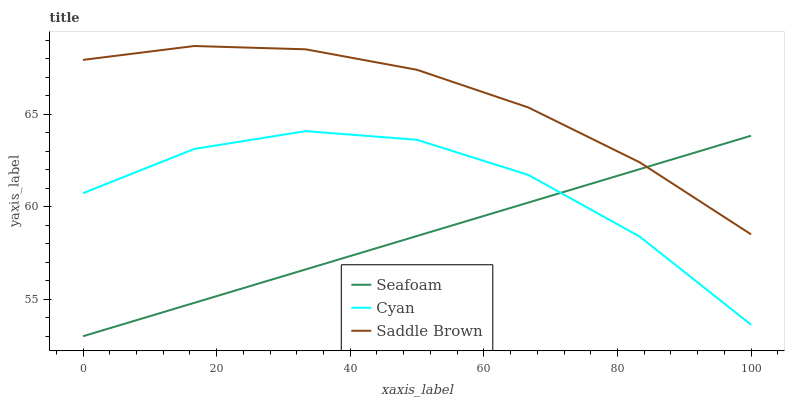Does Seafoam have the minimum area under the curve?
Answer yes or no. Yes. Does Saddle Brown have the maximum area under the curve?
Answer yes or no. Yes. Does Saddle Brown have the minimum area under the curve?
Answer yes or no. No. Does Seafoam have the maximum area under the curve?
Answer yes or no. No. Is Seafoam the smoothest?
Answer yes or no. Yes. Is Cyan the roughest?
Answer yes or no. Yes. Is Saddle Brown the smoothest?
Answer yes or no. No. Is Saddle Brown the roughest?
Answer yes or no. No. Does Saddle Brown have the lowest value?
Answer yes or no. No. Does Saddle Brown have the highest value?
Answer yes or no. Yes. Does Seafoam have the highest value?
Answer yes or no. No. Is Cyan less than Saddle Brown?
Answer yes or no. Yes. Is Saddle Brown greater than Cyan?
Answer yes or no. Yes. Does Seafoam intersect Saddle Brown?
Answer yes or no. Yes. Is Seafoam less than Saddle Brown?
Answer yes or no. No. Is Seafoam greater than Saddle Brown?
Answer yes or no. No. Does Cyan intersect Saddle Brown?
Answer yes or no. No. 